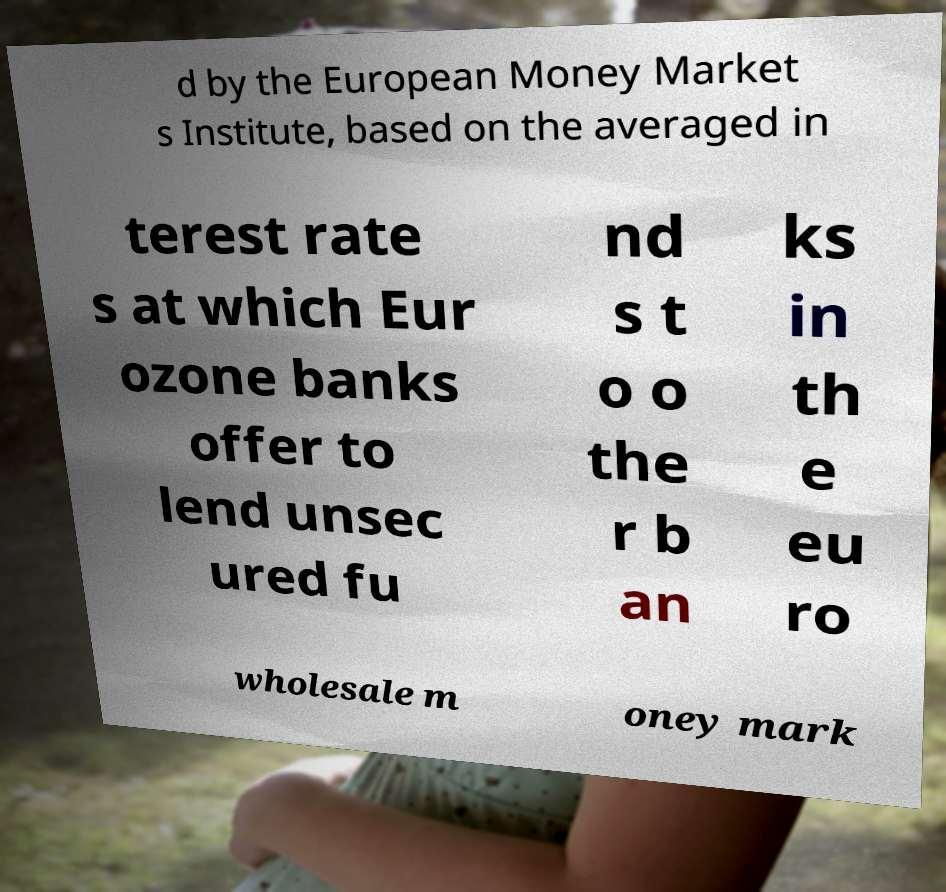Please identify and transcribe the text found in this image. d by the European Money Market s Institute, based on the averaged in terest rate s at which Eur ozone banks offer to lend unsec ured fu nd s t o o the r b an ks in th e eu ro wholesale m oney mark 